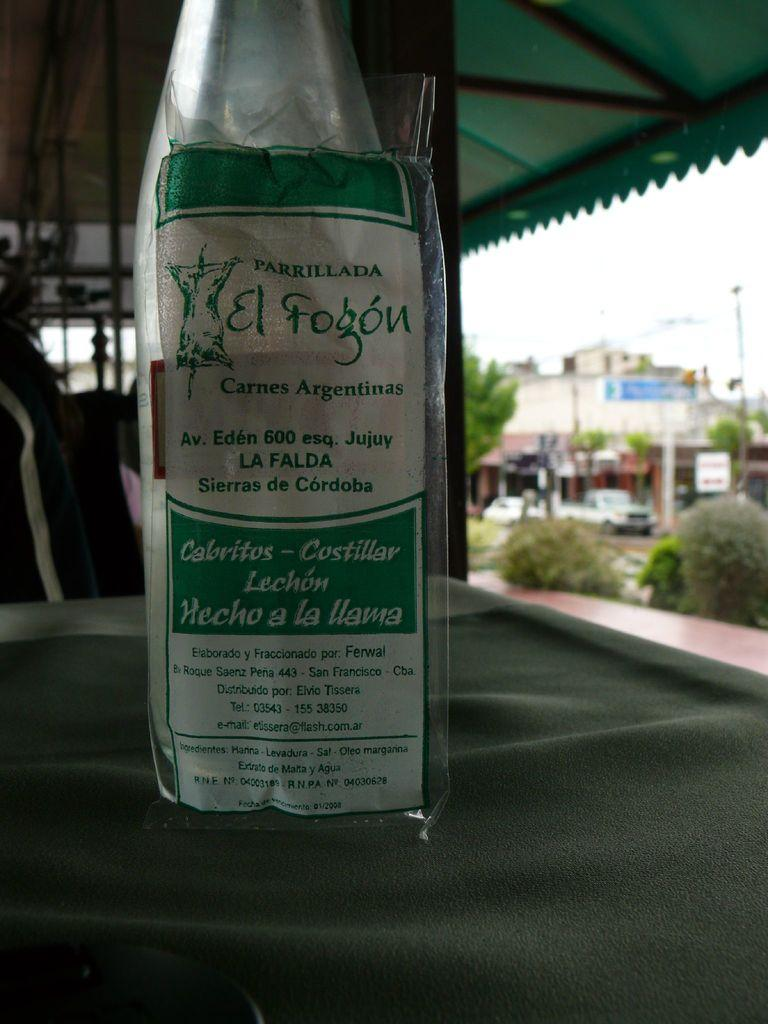<image>
Write a terse but informative summary of the picture. A bottle with green and white label that reads el fogon. 